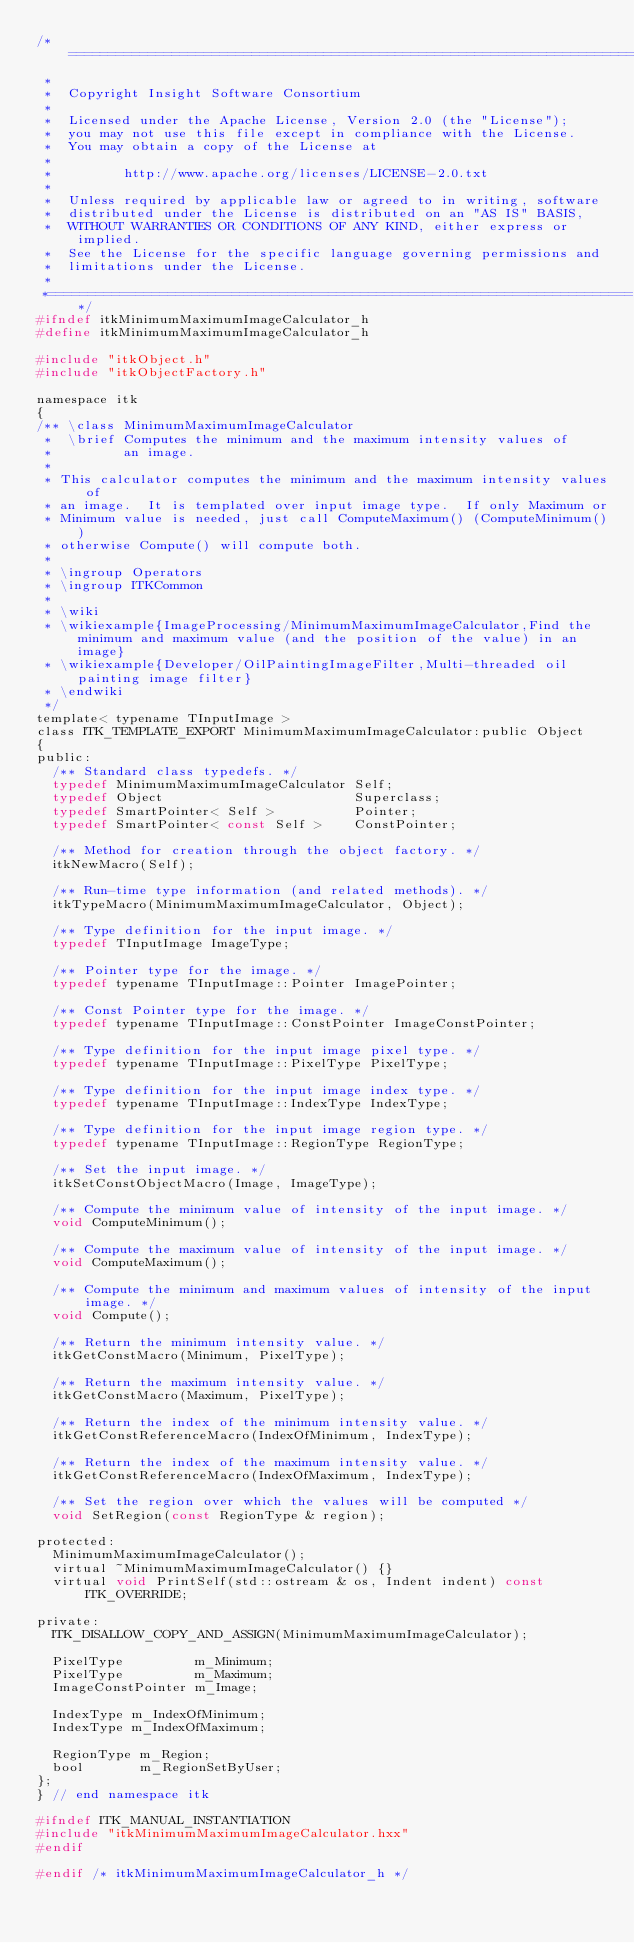Convert code to text. <code><loc_0><loc_0><loc_500><loc_500><_C_>/*=========================================================================
 *
 *  Copyright Insight Software Consortium
 *
 *  Licensed under the Apache License, Version 2.0 (the "License");
 *  you may not use this file except in compliance with the License.
 *  You may obtain a copy of the License at
 *
 *         http://www.apache.org/licenses/LICENSE-2.0.txt
 *
 *  Unless required by applicable law or agreed to in writing, software
 *  distributed under the License is distributed on an "AS IS" BASIS,
 *  WITHOUT WARRANTIES OR CONDITIONS OF ANY KIND, either express or implied.
 *  See the License for the specific language governing permissions and
 *  limitations under the License.
 *
 *=========================================================================*/
#ifndef itkMinimumMaximumImageCalculator_h
#define itkMinimumMaximumImageCalculator_h

#include "itkObject.h"
#include "itkObjectFactory.h"

namespace itk
{
/** \class MinimumMaximumImageCalculator
 *  \brief Computes the minimum and the maximum intensity values of
 *         an image.
 *
 * This calculator computes the minimum and the maximum intensity values of
 * an image.  It is templated over input image type.  If only Maximum or
 * Minimum value is needed, just call ComputeMaximum() (ComputeMinimum())
 * otherwise Compute() will compute both.
 *
 * \ingroup Operators
 * \ingroup ITKCommon
 *
 * \wiki
 * \wikiexample{ImageProcessing/MinimumMaximumImageCalculator,Find the minimum and maximum value (and the position of the value) in an image}
 * \wikiexample{Developer/OilPaintingImageFilter,Multi-threaded oil painting image filter}
 * \endwiki
 */
template< typename TInputImage >
class ITK_TEMPLATE_EXPORT MinimumMaximumImageCalculator:public Object
{
public:
  /** Standard class typedefs. */
  typedef MinimumMaximumImageCalculator Self;
  typedef Object                        Superclass;
  typedef SmartPointer< Self >          Pointer;
  typedef SmartPointer< const Self >    ConstPointer;

  /** Method for creation through the object factory. */
  itkNewMacro(Self);

  /** Run-time type information (and related methods). */
  itkTypeMacro(MinimumMaximumImageCalculator, Object);

  /** Type definition for the input image. */
  typedef TInputImage ImageType;

  /** Pointer type for the image. */
  typedef typename TInputImage::Pointer ImagePointer;

  /** Const Pointer type for the image. */
  typedef typename TInputImage::ConstPointer ImageConstPointer;

  /** Type definition for the input image pixel type. */
  typedef typename TInputImage::PixelType PixelType;

  /** Type definition for the input image index type. */
  typedef typename TInputImage::IndexType IndexType;

  /** Type definition for the input image region type. */
  typedef typename TInputImage::RegionType RegionType;

  /** Set the input image. */
  itkSetConstObjectMacro(Image, ImageType);

  /** Compute the minimum value of intensity of the input image. */
  void ComputeMinimum();

  /** Compute the maximum value of intensity of the input image. */
  void ComputeMaximum();

  /** Compute the minimum and maximum values of intensity of the input image. */
  void Compute();

  /** Return the minimum intensity value. */
  itkGetConstMacro(Minimum, PixelType);

  /** Return the maximum intensity value. */
  itkGetConstMacro(Maximum, PixelType);

  /** Return the index of the minimum intensity value. */
  itkGetConstReferenceMacro(IndexOfMinimum, IndexType);

  /** Return the index of the maximum intensity value. */
  itkGetConstReferenceMacro(IndexOfMaximum, IndexType);

  /** Set the region over which the values will be computed */
  void SetRegion(const RegionType & region);

protected:
  MinimumMaximumImageCalculator();
  virtual ~MinimumMaximumImageCalculator() {}
  virtual void PrintSelf(std::ostream & os, Indent indent) const ITK_OVERRIDE;

private:
  ITK_DISALLOW_COPY_AND_ASSIGN(MinimumMaximumImageCalculator);

  PixelType         m_Minimum;
  PixelType         m_Maximum;
  ImageConstPointer m_Image;

  IndexType m_IndexOfMinimum;
  IndexType m_IndexOfMaximum;

  RegionType m_Region;
  bool       m_RegionSetByUser;
};
} // end namespace itk

#ifndef ITK_MANUAL_INSTANTIATION
#include "itkMinimumMaximumImageCalculator.hxx"
#endif

#endif /* itkMinimumMaximumImageCalculator_h */
</code> 